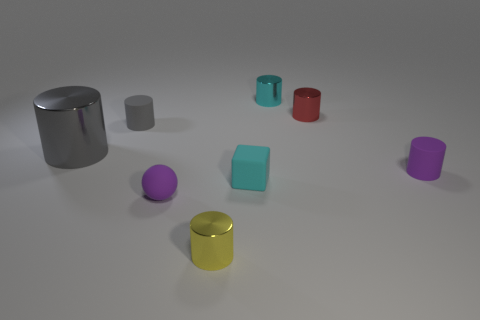What number of spheres are either tiny blue objects or tiny yellow shiny things?
Provide a short and direct response. 0. Is there anything else of the same color as the tiny rubber sphere?
Give a very brief answer. Yes. There is a tiny purple object that is on the right side of the tiny ball in front of the tiny purple cylinder; what is it made of?
Your answer should be compact. Rubber. Is the material of the small cube the same as the tiny purple thing that is on the left side of the tiny yellow metal thing?
Offer a very short reply. Yes. How many things are either cyan things that are behind the large gray cylinder or tiny cyan blocks?
Ensure brevity in your answer.  2. Is there another metallic object of the same color as the large object?
Ensure brevity in your answer.  No. There is a small yellow metallic object; is its shape the same as the cyan thing in front of the small red shiny object?
Offer a terse response. No. What number of rubber objects are both behind the block and on the left side of the cyan matte cube?
Offer a terse response. 1. There is a small purple thing that is the same shape as the gray matte object; what is its material?
Make the answer very short. Rubber. There is a thing that is in front of the tiny purple rubber thing that is in front of the purple rubber cylinder; what is its size?
Provide a succinct answer. Small. 